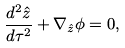Convert formula to latex. <formula><loc_0><loc_0><loc_500><loc_500>\frac { d ^ { 2 } \hat { z } } { d \tau ^ { 2 } } + \nabla _ { \hat { z } } \phi = 0 ,</formula> 